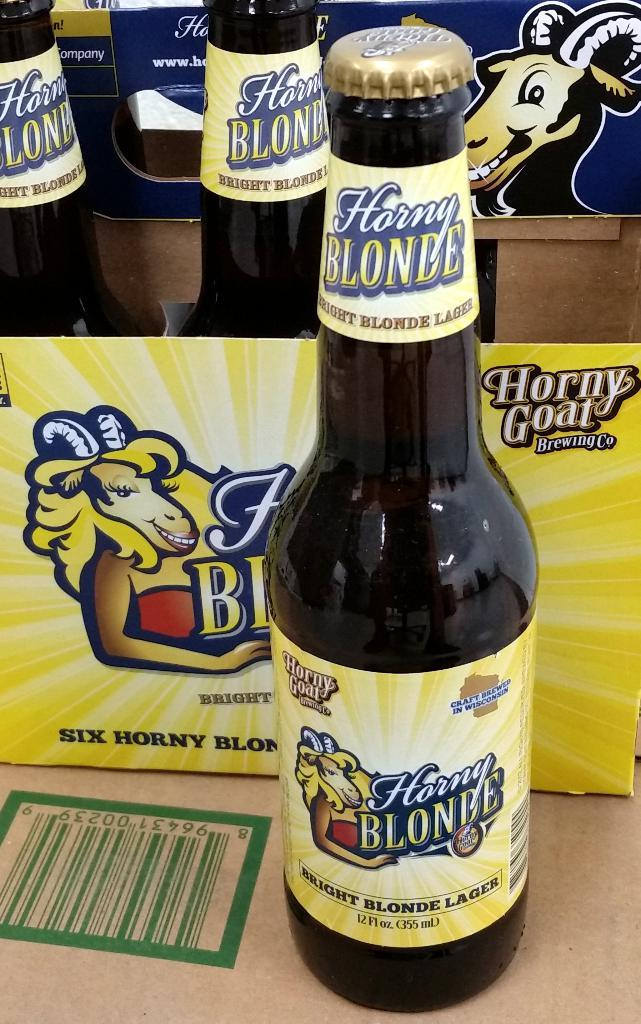<image>
Create a compact narrative representing the image presented. A bottle of beer from Horny Goat Brewing company is sitting next to its box. 